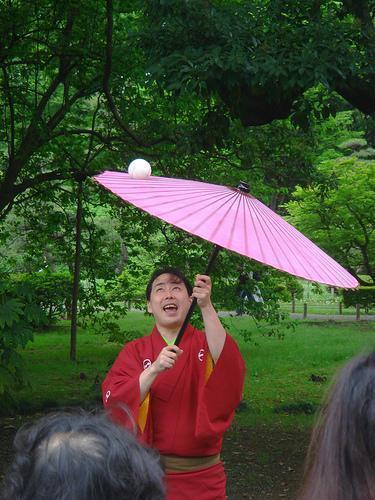Why is the ball on the parasol?
Answer the question by selecting the correct answer among the 4 following choices and explain your choice with a short sentence. The answer should be formatted with the following format: `Answer: choice
Rationale: rationale.`
Options: Is random, landed there, is trick, fell there. Answer: is trick.
Rationale: It looks like the person with the umbrella is entertaining the other people. 